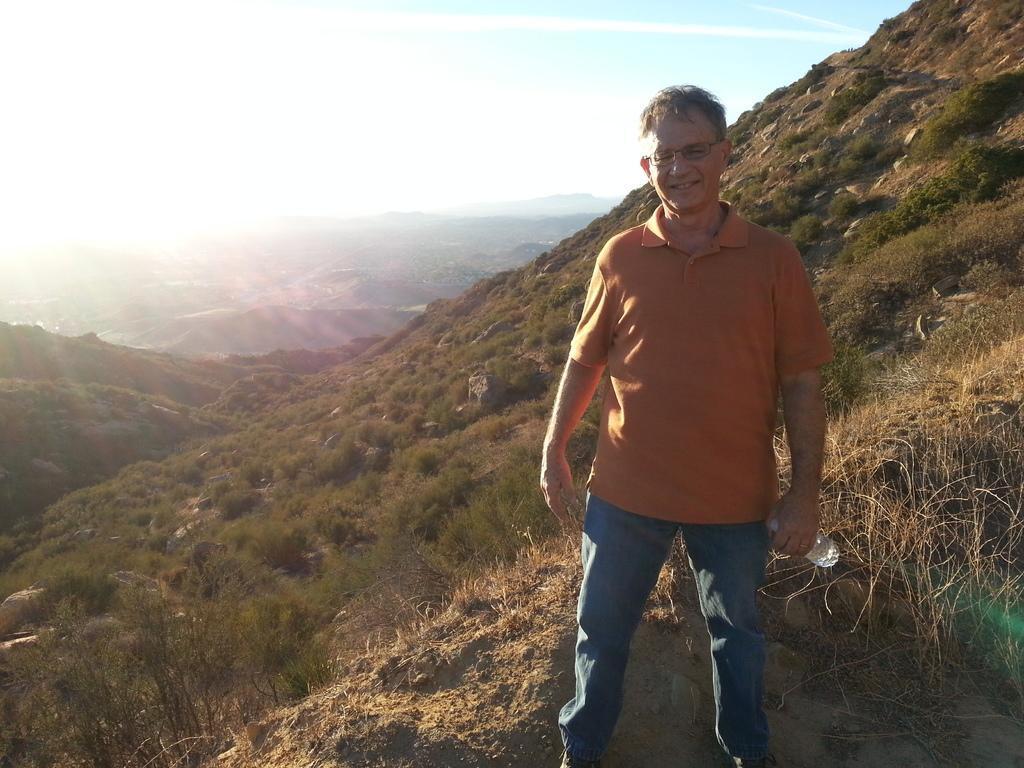Describe this image in one or two sentences. In this image there is a person standing and smiling by holding a bottle, and in the background there are trees, hills,sky. 